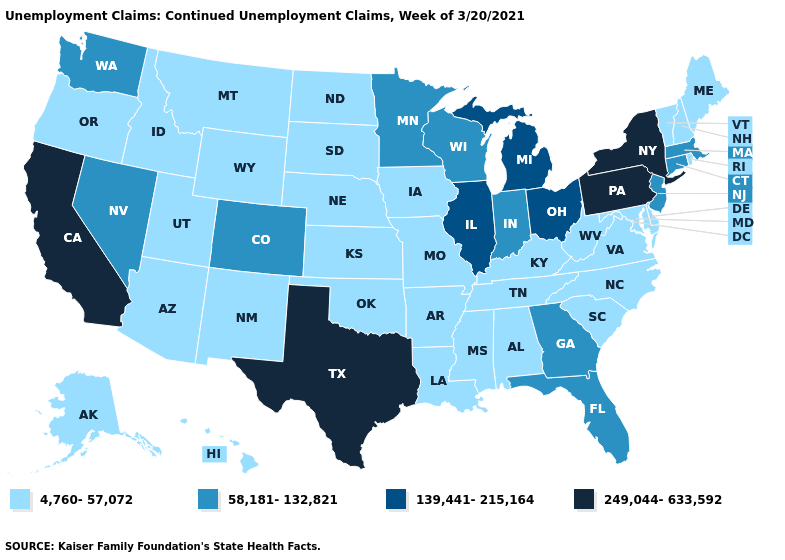Which states have the lowest value in the USA?
Quick response, please. Alabama, Alaska, Arizona, Arkansas, Delaware, Hawaii, Idaho, Iowa, Kansas, Kentucky, Louisiana, Maine, Maryland, Mississippi, Missouri, Montana, Nebraska, New Hampshire, New Mexico, North Carolina, North Dakota, Oklahoma, Oregon, Rhode Island, South Carolina, South Dakota, Tennessee, Utah, Vermont, Virginia, West Virginia, Wyoming. What is the highest value in states that border New Hampshire?
Concise answer only. 58,181-132,821. What is the value of New Hampshire?
Concise answer only. 4,760-57,072. What is the lowest value in the Northeast?
Be succinct. 4,760-57,072. Does Utah have the lowest value in the West?
Answer briefly. Yes. Name the states that have a value in the range 4,760-57,072?
Short answer required. Alabama, Alaska, Arizona, Arkansas, Delaware, Hawaii, Idaho, Iowa, Kansas, Kentucky, Louisiana, Maine, Maryland, Mississippi, Missouri, Montana, Nebraska, New Hampshire, New Mexico, North Carolina, North Dakota, Oklahoma, Oregon, Rhode Island, South Carolina, South Dakota, Tennessee, Utah, Vermont, Virginia, West Virginia, Wyoming. Which states have the lowest value in the USA?
Keep it brief. Alabama, Alaska, Arizona, Arkansas, Delaware, Hawaii, Idaho, Iowa, Kansas, Kentucky, Louisiana, Maine, Maryland, Mississippi, Missouri, Montana, Nebraska, New Hampshire, New Mexico, North Carolina, North Dakota, Oklahoma, Oregon, Rhode Island, South Carolina, South Dakota, Tennessee, Utah, Vermont, Virginia, West Virginia, Wyoming. Which states have the lowest value in the USA?
Be succinct. Alabama, Alaska, Arizona, Arkansas, Delaware, Hawaii, Idaho, Iowa, Kansas, Kentucky, Louisiana, Maine, Maryland, Mississippi, Missouri, Montana, Nebraska, New Hampshire, New Mexico, North Carolina, North Dakota, Oklahoma, Oregon, Rhode Island, South Carolina, South Dakota, Tennessee, Utah, Vermont, Virginia, West Virginia, Wyoming. Does Maine have a lower value than Ohio?
Be succinct. Yes. What is the value of Rhode Island?
Answer briefly. 4,760-57,072. Which states have the lowest value in the USA?
Give a very brief answer. Alabama, Alaska, Arizona, Arkansas, Delaware, Hawaii, Idaho, Iowa, Kansas, Kentucky, Louisiana, Maine, Maryland, Mississippi, Missouri, Montana, Nebraska, New Hampshire, New Mexico, North Carolina, North Dakota, Oklahoma, Oregon, Rhode Island, South Carolina, South Dakota, Tennessee, Utah, Vermont, Virginia, West Virginia, Wyoming. Does Indiana have the lowest value in the MidWest?
Write a very short answer. No. Does Arkansas have a lower value than New Jersey?
Concise answer only. Yes. What is the value of Indiana?
Give a very brief answer. 58,181-132,821. 